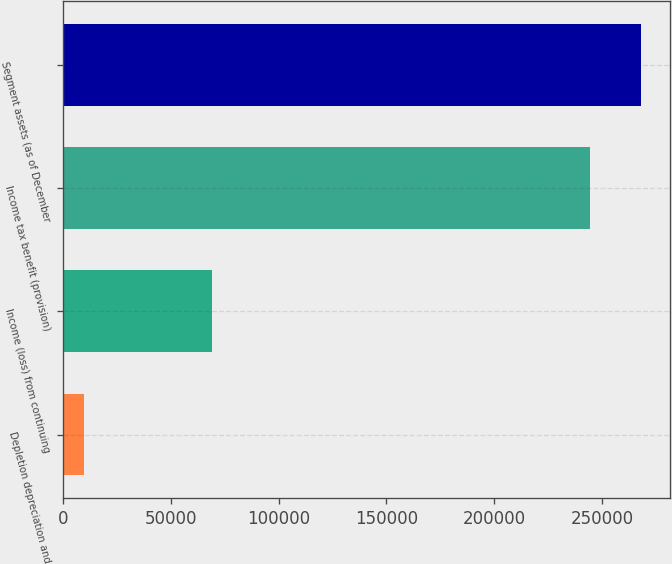Convert chart to OTSL. <chart><loc_0><loc_0><loc_500><loc_500><bar_chart><fcel>Depletion depreciation and<fcel>Income (loss) from continuing<fcel>Income tax benefit (provision)<fcel>Segment assets (as of December<nl><fcel>9597<fcel>69005<fcel>244583<fcel>268256<nl></chart> 